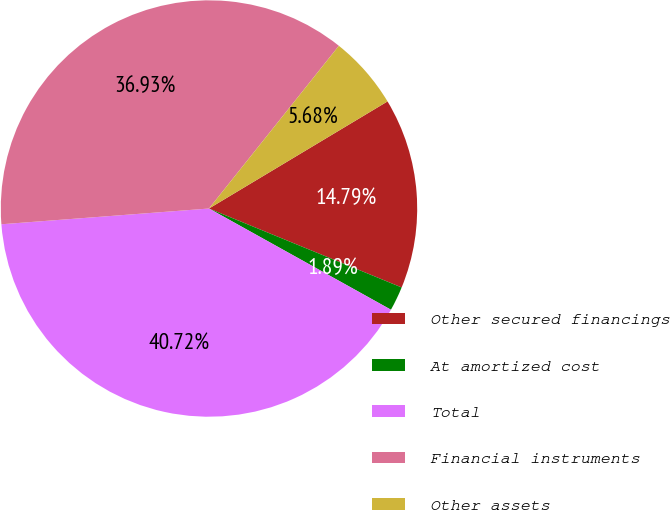Convert chart. <chart><loc_0><loc_0><loc_500><loc_500><pie_chart><fcel>Other secured financings<fcel>At amortized cost<fcel>Total<fcel>Financial instruments<fcel>Other assets<nl><fcel>14.79%<fcel>1.89%<fcel>40.72%<fcel>36.93%<fcel>5.68%<nl></chart> 